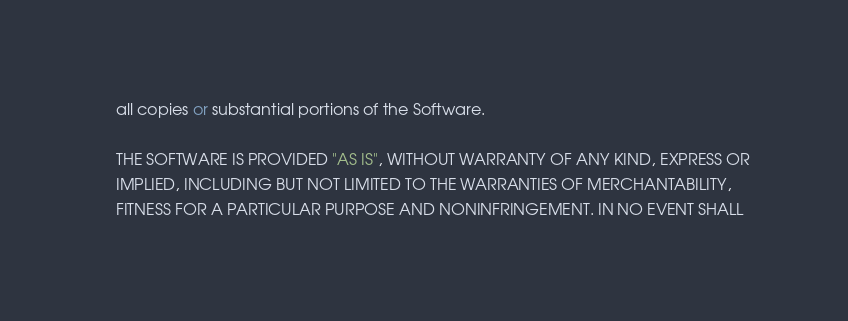Convert code to text. <code><loc_0><loc_0><loc_500><loc_500><_C++_>    all copies or substantial portions of the Software.

    THE SOFTWARE IS PROVIDED "AS IS", WITHOUT WARRANTY OF ANY KIND, EXPRESS OR
    IMPLIED, INCLUDING BUT NOT LIMITED TO THE WARRANTIES OF MERCHANTABILITY,
    FITNESS FOR A PARTICULAR PURPOSE AND NONINFRINGEMENT. IN NO EVENT SHALL</code> 